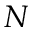<formula> <loc_0><loc_0><loc_500><loc_500>N</formula> 